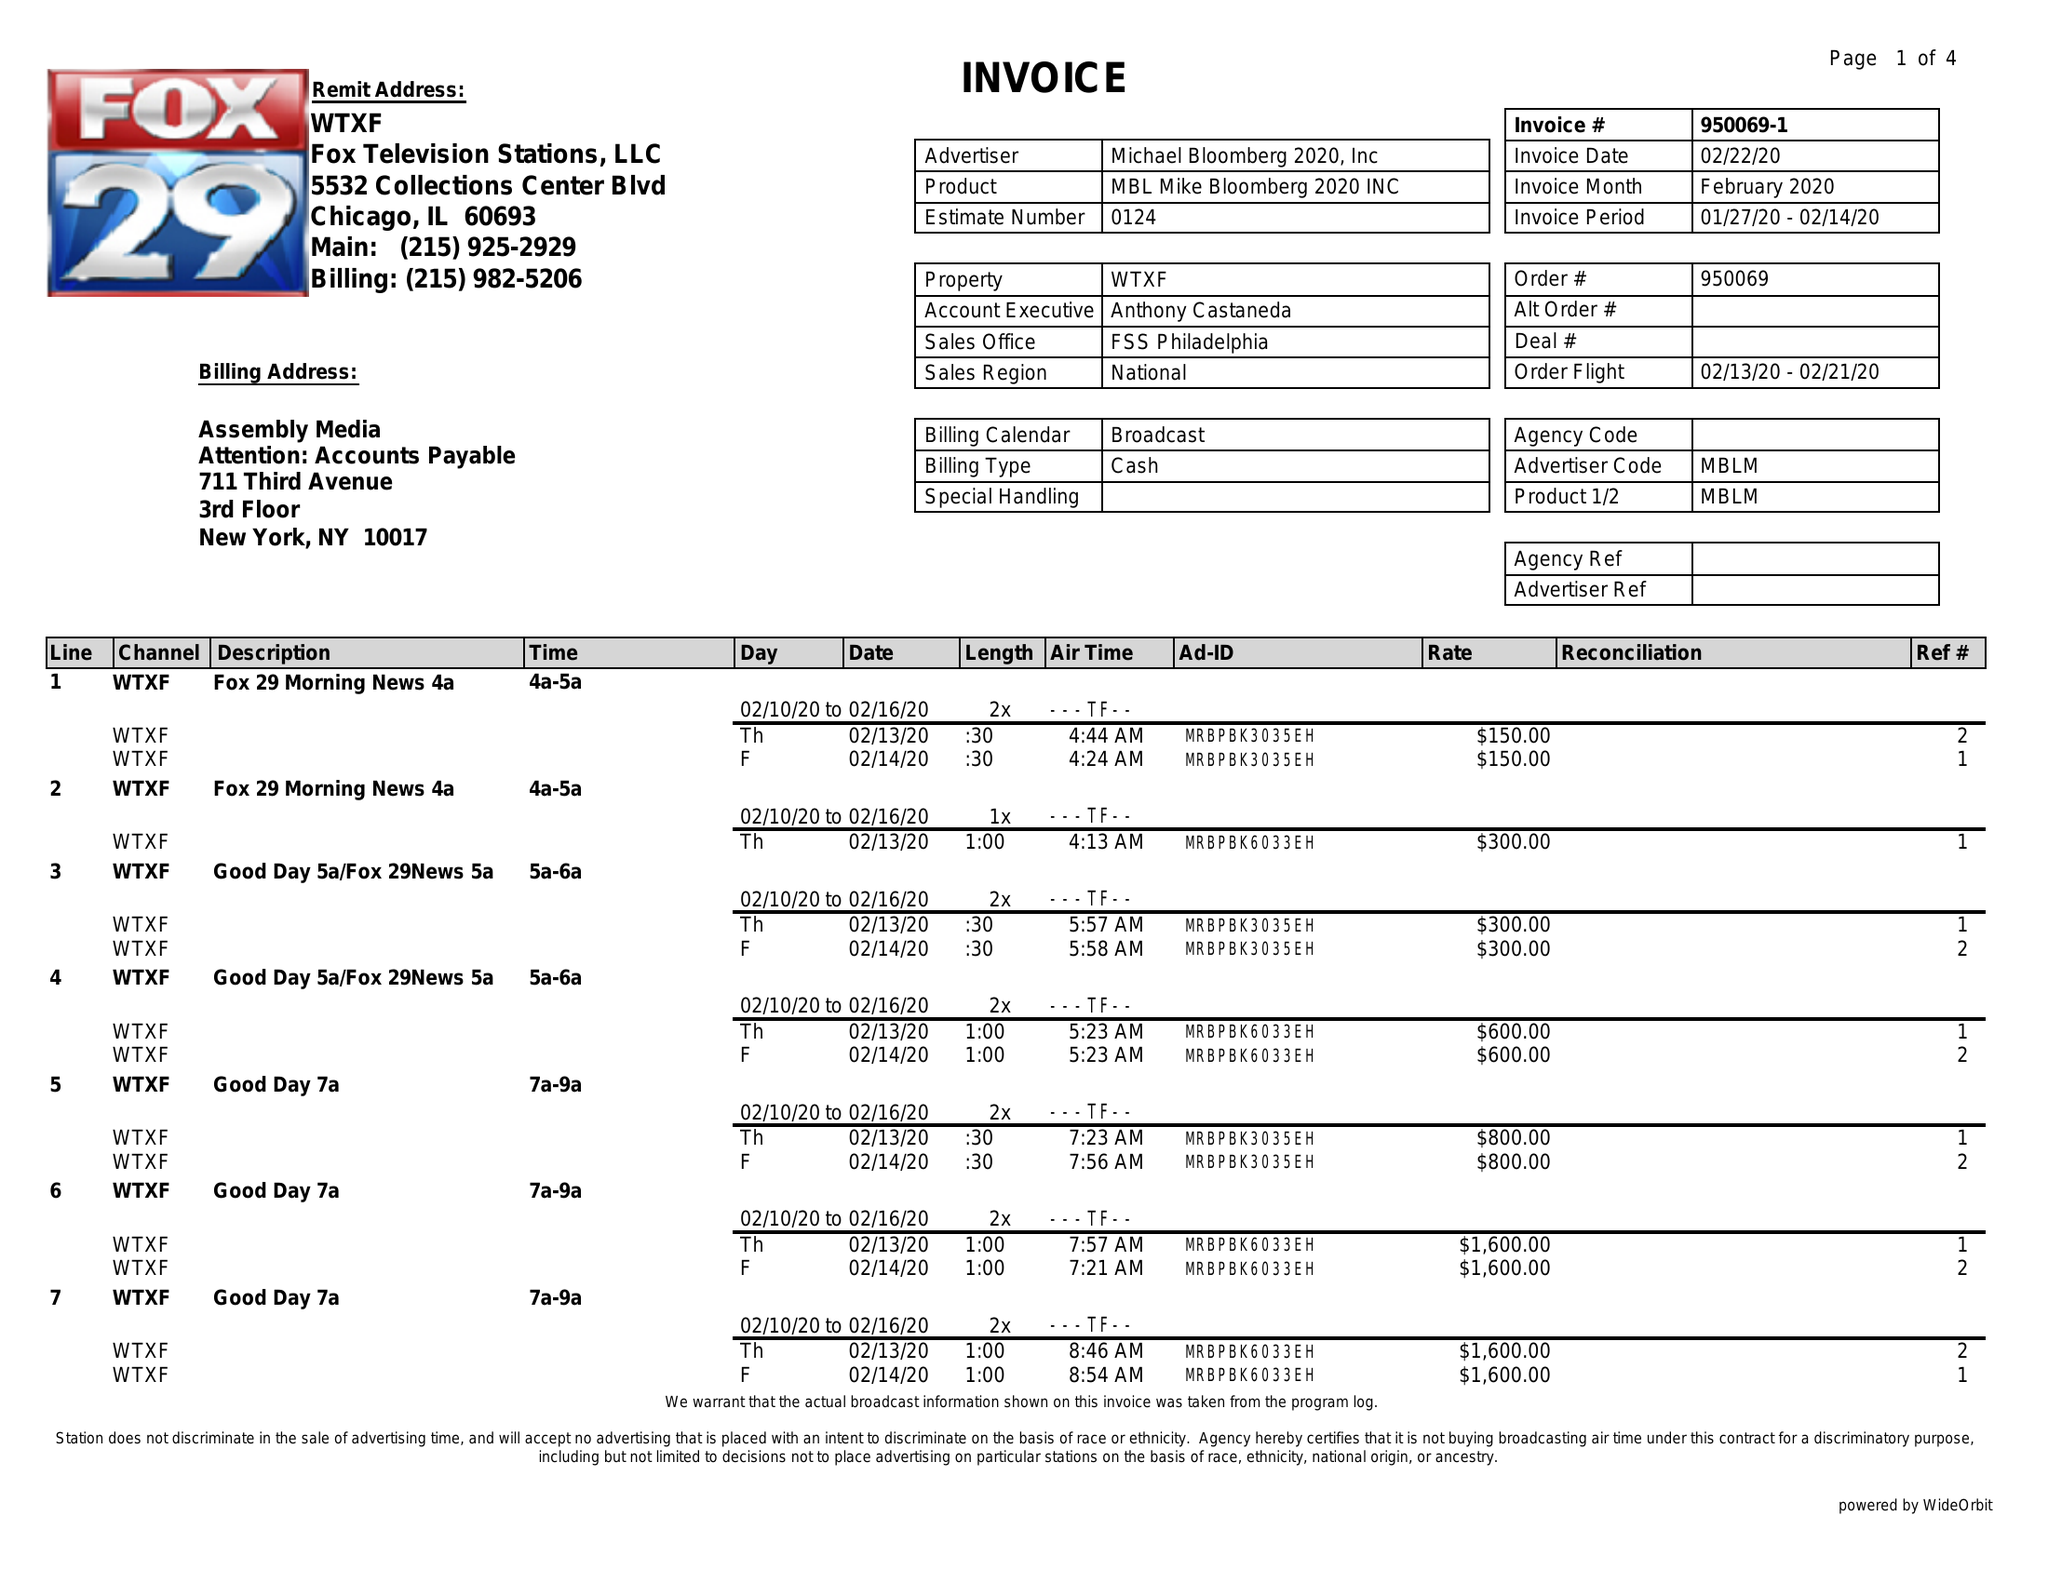What is the value for the advertiser?
Answer the question using a single word or phrase. MICHAEL BLOOMBERG 2020, INC 